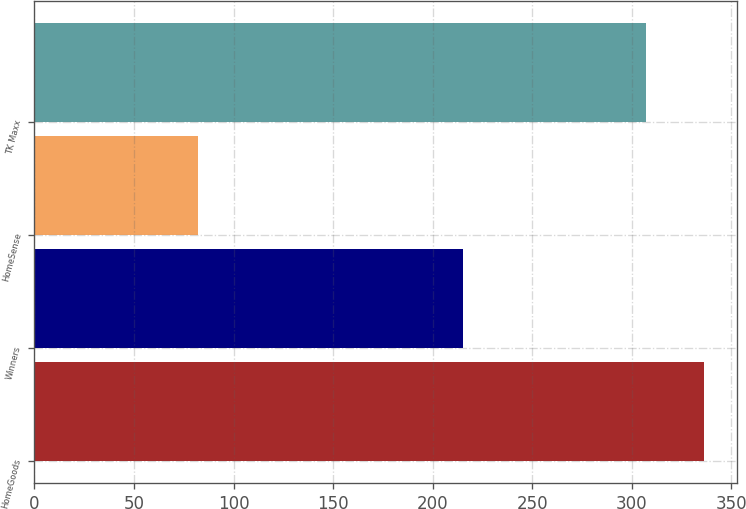Convert chart. <chart><loc_0><loc_0><loc_500><loc_500><bar_chart><fcel>HomeGoods<fcel>Winners<fcel>HomeSense<fcel>TK Maxx<nl><fcel>336<fcel>215<fcel>82<fcel>307<nl></chart> 